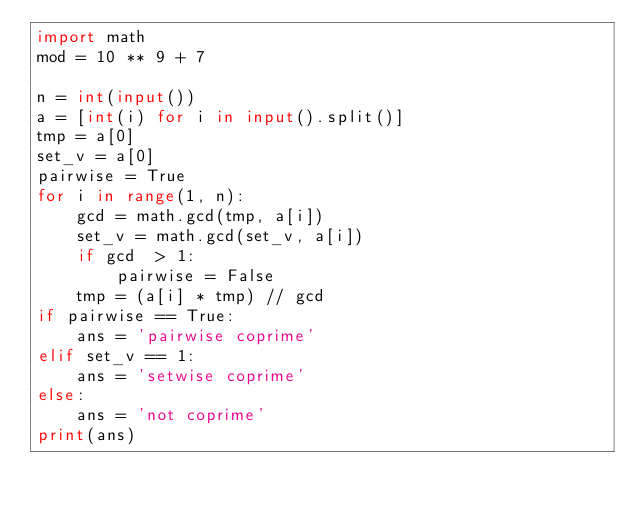<code> <loc_0><loc_0><loc_500><loc_500><_Python_>import math
mod = 10 ** 9 + 7

n = int(input())
a = [int(i) for i in input().split()]
tmp = a[0]
set_v = a[0]
pairwise = True
for i in range(1, n):
    gcd = math.gcd(tmp, a[i])
    set_v = math.gcd(set_v, a[i])
    if gcd  > 1:
        pairwise = False
    tmp = (a[i] * tmp) // gcd
if pairwise == True:
    ans = 'pairwise coprime'
elif set_v == 1:
    ans = 'setwise coprime'
else:
    ans = 'not coprime'
print(ans)</code> 